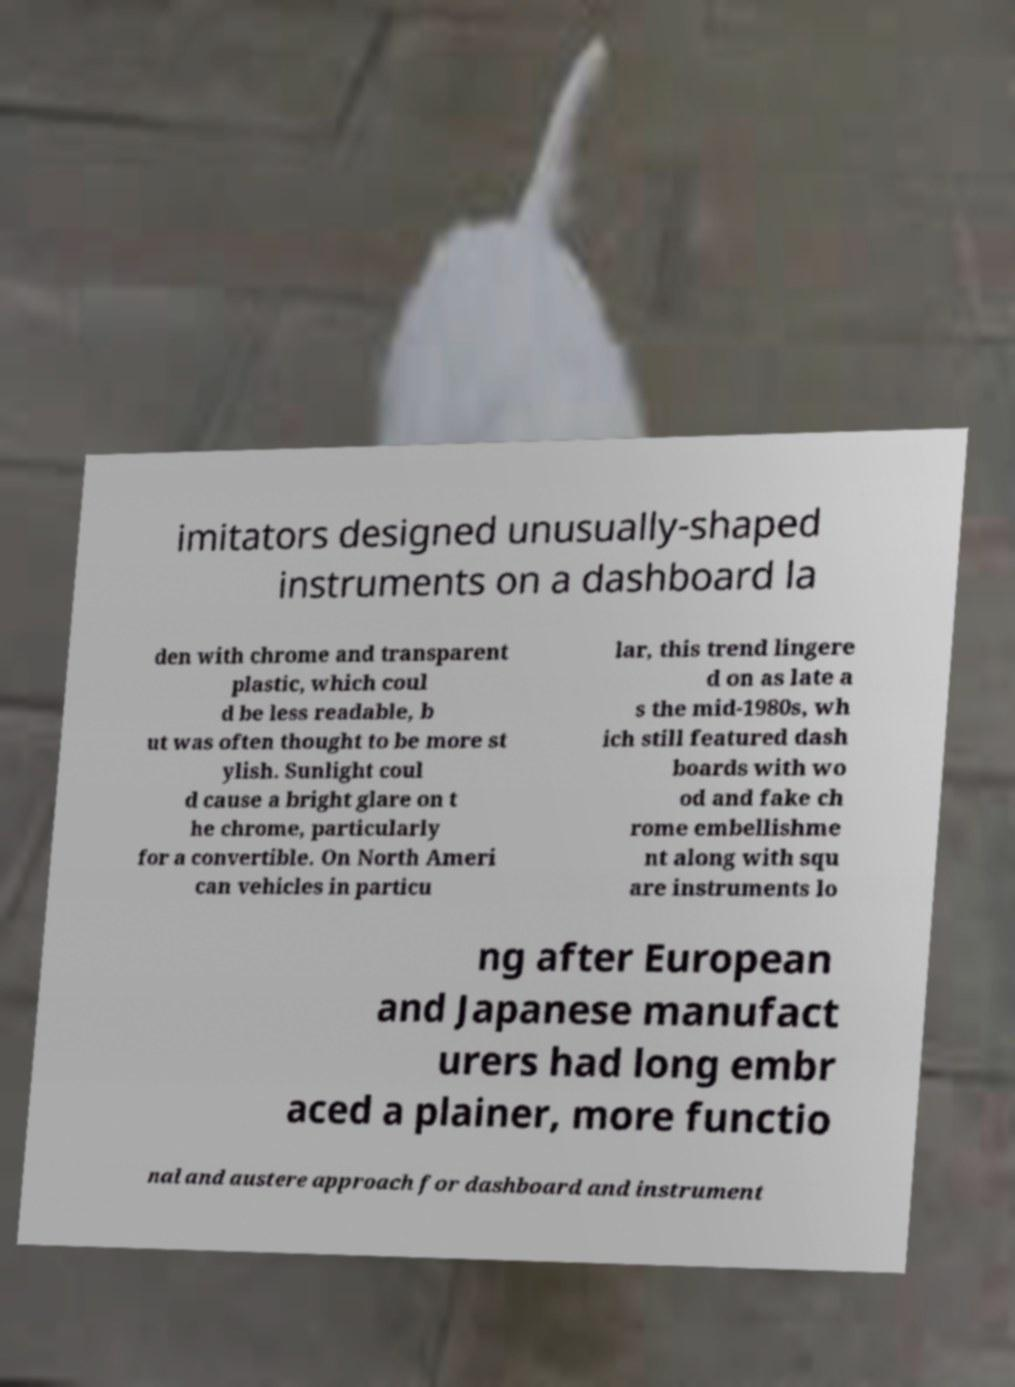There's text embedded in this image that I need extracted. Can you transcribe it verbatim? imitators designed unusually-shaped instruments on a dashboard la den with chrome and transparent plastic, which coul d be less readable, b ut was often thought to be more st ylish. Sunlight coul d cause a bright glare on t he chrome, particularly for a convertible. On North Ameri can vehicles in particu lar, this trend lingere d on as late a s the mid-1980s, wh ich still featured dash boards with wo od and fake ch rome embellishme nt along with squ are instruments lo ng after European and Japanese manufact urers had long embr aced a plainer, more functio nal and austere approach for dashboard and instrument 